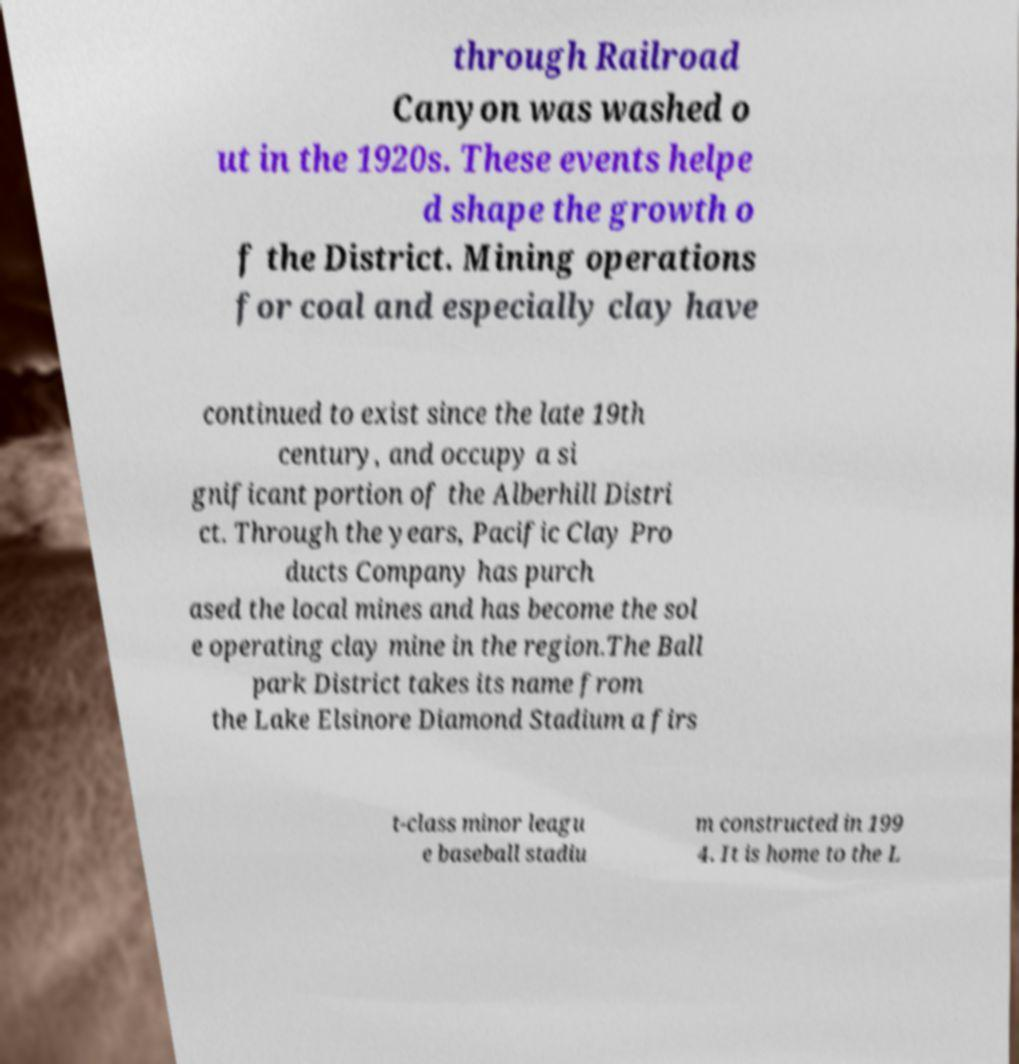Can you accurately transcribe the text from the provided image for me? through Railroad Canyon was washed o ut in the 1920s. These events helpe d shape the growth o f the District. Mining operations for coal and especially clay have continued to exist since the late 19th century, and occupy a si gnificant portion of the Alberhill Distri ct. Through the years, Pacific Clay Pro ducts Company has purch ased the local mines and has become the sol e operating clay mine in the region.The Ball park District takes its name from the Lake Elsinore Diamond Stadium a firs t-class minor leagu e baseball stadiu m constructed in 199 4. It is home to the L 